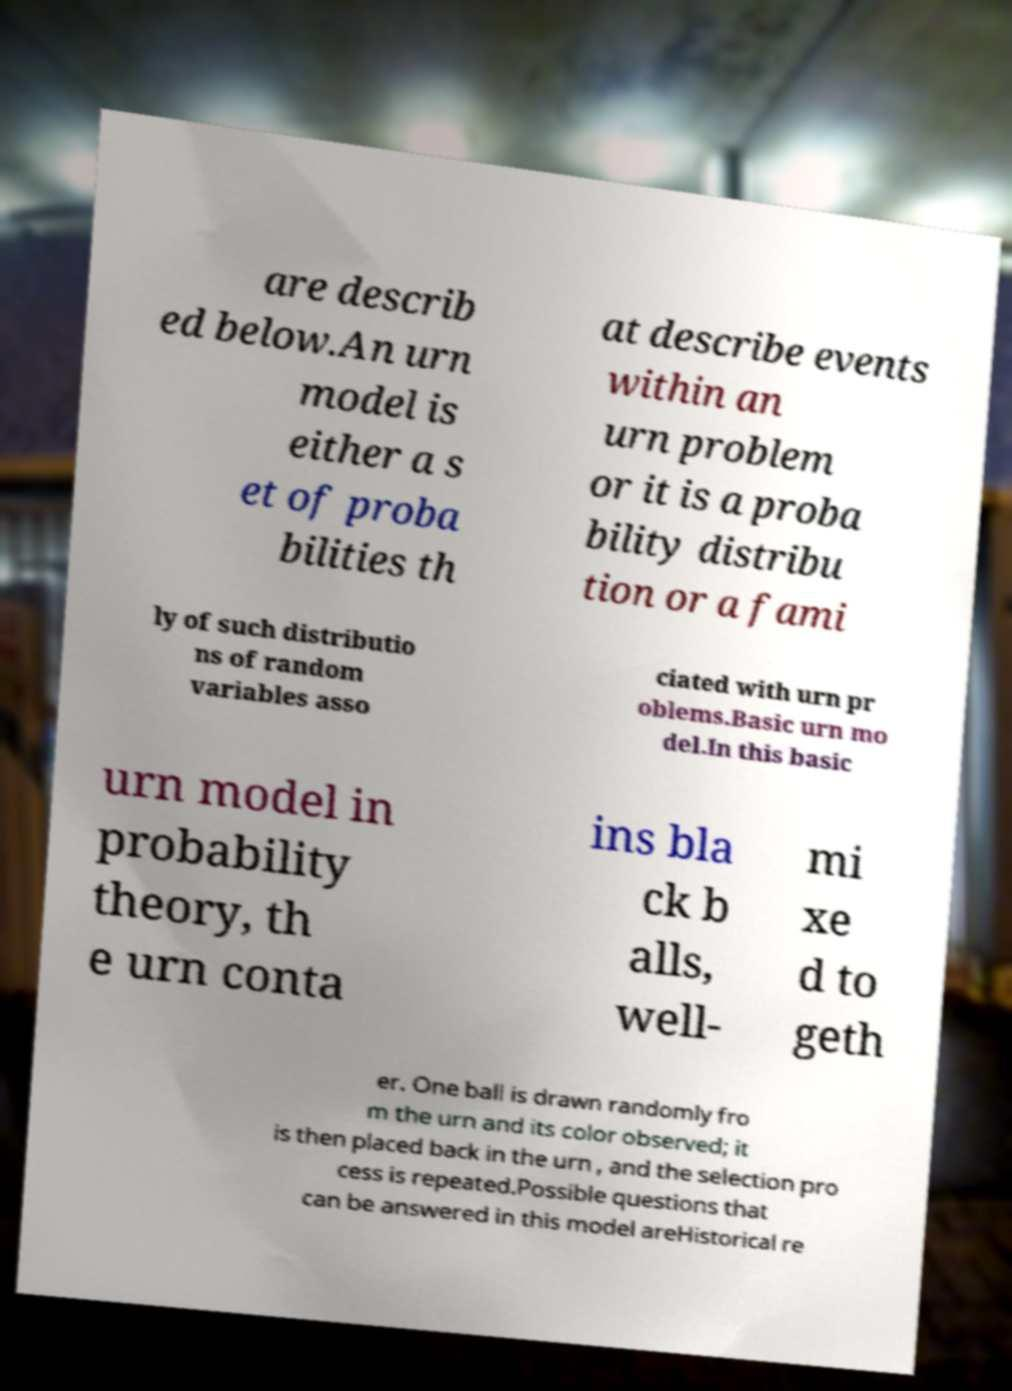What messages or text are displayed in this image? I need them in a readable, typed format. are describ ed below.An urn model is either a s et of proba bilities th at describe events within an urn problem or it is a proba bility distribu tion or a fami ly of such distributio ns of random variables asso ciated with urn pr oblems.Basic urn mo del.In this basic urn model in probability theory, th e urn conta ins bla ck b alls, well- mi xe d to geth er. One ball is drawn randomly fro m the urn and its color observed; it is then placed back in the urn , and the selection pro cess is repeated.Possible questions that can be answered in this model areHistorical re 